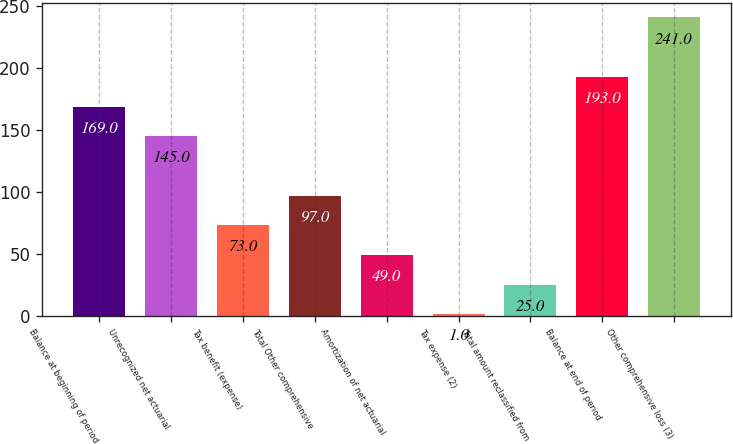Convert chart. <chart><loc_0><loc_0><loc_500><loc_500><bar_chart><fcel>Balance at beginning of period<fcel>Unrecognized net actuarial<fcel>Tax benefit (expense)<fcel>Total Other comprehensive<fcel>Amortization of net actuarial<fcel>Tax expense (2)<fcel>Total amount reclassified from<fcel>Balance at end of period<fcel>Other comprehensive loss (3)<nl><fcel>169<fcel>145<fcel>73<fcel>97<fcel>49<fcel>1<fcel>25<fcel>193<fcel>241<nl></chart> 